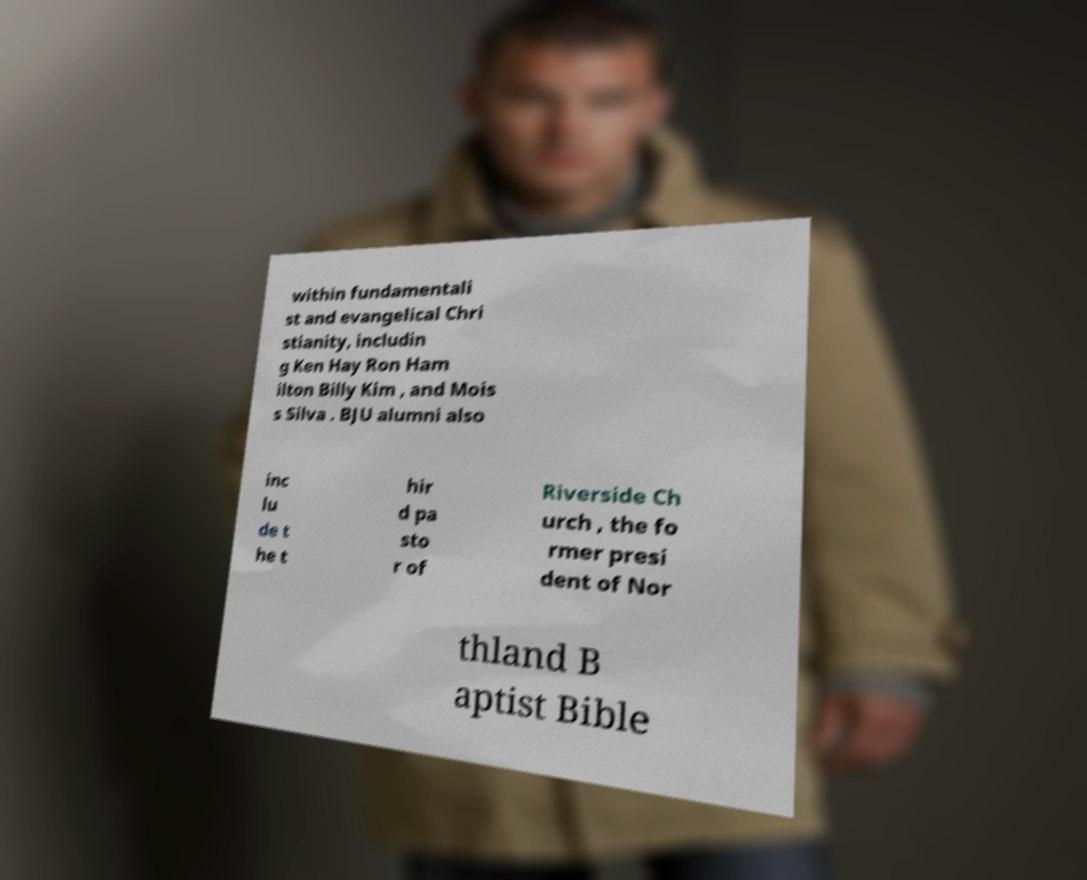Please identify and transcribe the text found in this image. within fundamentali st and evangelical Chri stianity, includin g Ken Hay Ron Ham ilton Billy Kim , and Mois s Silva . BJU alumni also inc lu de t he t hir d pa sto r of Riverside Ch urch , the fo rmer presi dent of Nor thland B aptist Bible 